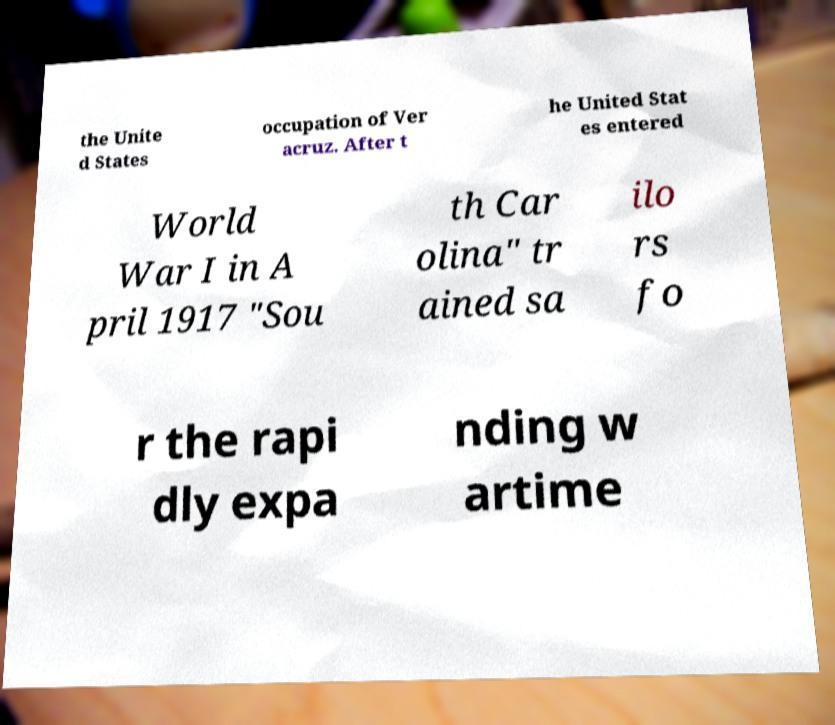There's text embedded in this image that I need extracted. Can you transcribe it verbatim? the Unite d States occupation of Ver acruz. After t he United Stat es entered World War I in A pril 1917 "Sou th Car olina" tr ained sa ilo rs fo r the rapi dly expa nding w artime 